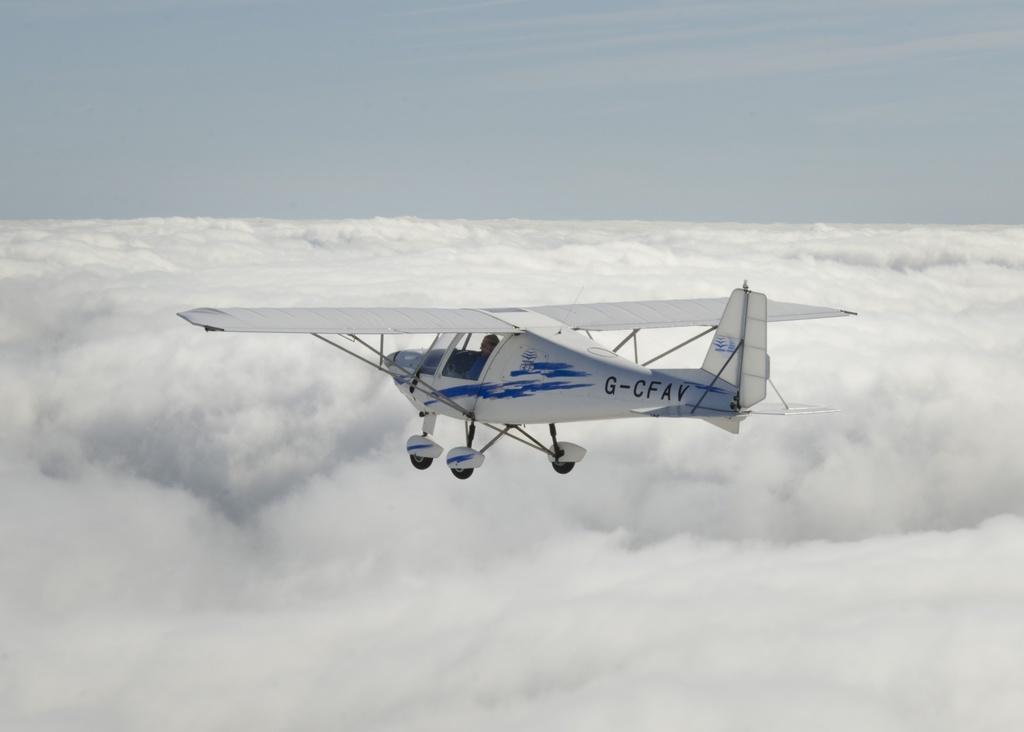Can you describe this image briefly? In this picture we can observe an airplane which is in white color flying in the air. This airplane is flying above the clouds. In the background we can observe a sky and clouds. 